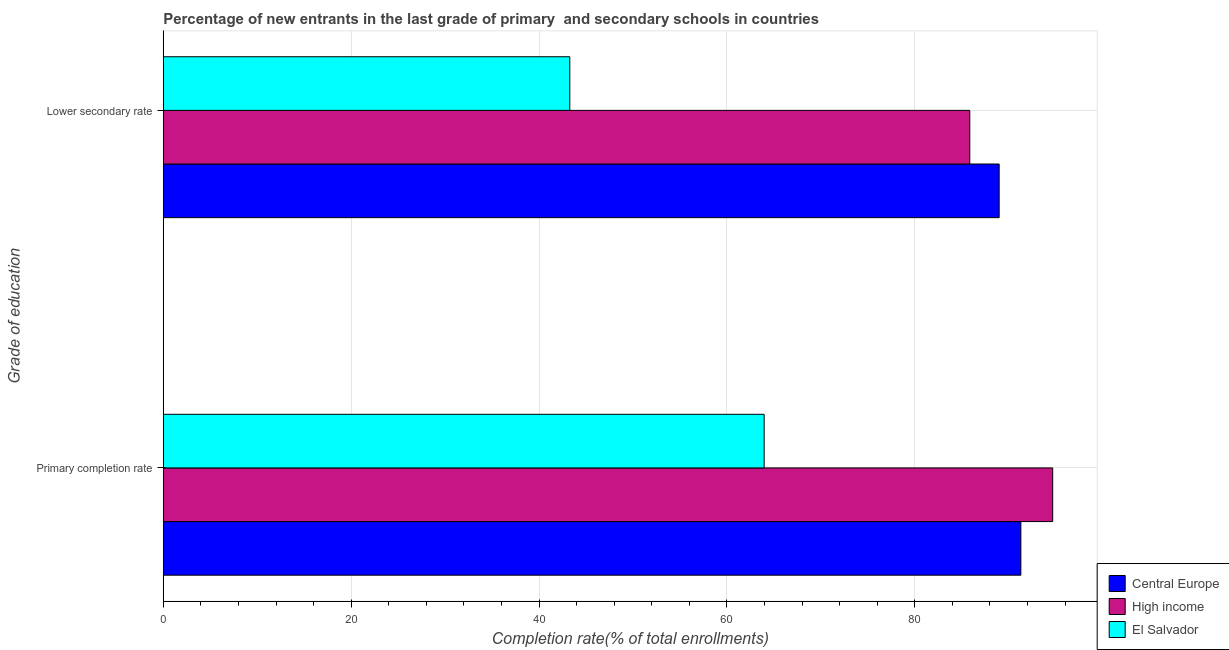Are the number of bars per tick equal to the number of legend labels?
Provide a short and direct response. Yes. How many bars are there on the 1st tick from the top?
Your answer should be compact. 3. How many bars are there on the 2nd tick from the bottom?
Offer a very short reply. 3. What is the label of the 1st group of bars from the top?
Make the answer very short. Lower secondary rate. What is the completion rate in primary schools in Central Europe?
Your response must be concise. 91.29. Across all countries, what is the maximum completion rate in secondary schools?
Ensure brevity in your answer.  88.98. Across all countries, what is the minimum completion rate in secondary schools?
Your answer should be very brief. 43.28. In which country was the completion rate in primary schools maximum?
Your answer should be compact. High income. In which country was the completion rate in secondary schools minimum?
Provide a short and direct response. El Salvador. What is the total completion rate in secondary schools in the graph?
Offer a terse response. 218.11. What is the difference between the completion rate in secondary schools in High income and that in Central Europe?
Your answer should be compact. -3.13. What is the difference between the completion rate in primary schools in High income and the completion rate in secondary schools in Central Europe?
Your answer should be very brief. 5.7. What is the average completion rate in primary schools per country?
Ensure brevity in your answer.  83.31. What is the difference between the completion rate in secondary schools and completion rate in primary schools in Central Europe?
Provide a succinct answer. -2.31. In how many countries, is the completion rate in secondary schools greater than 36 %?
Provide a succinct answer. 3. What is the ratio of the completion rate in secondary schools in Central Europe to that in High income?
Your answer should be very brief. 1.04. Is the completion rate in primary schools in El Salvador less than that in Central Europe?
Your answer should be compact. Yes. What does the 2nd bar from the bottom in Lower secondary rate represents?
Your answer should be very brief. High income. How many bars are there?
Keep it short and to the point. 6. What is the difference between two consecutive major ticks on the X-axis?
Provide a short and direct response. 20. Are the values on the major ticks of X-axis written in scientific E-notation?
Your answer should be very brief. No. Does the graph contain any zero values?
Provide a short and direct response. No. Where does the legend appear in the graph?
Make the answer very short. Bottom right. What is the title of the graph?
Provide a short and direct response. Percentage of new entrants in the last grade of primary  and secondary schools in countries. What is the label or title of the X-axis?
Make the answer very short. Completion rate(% of total enrollments). What is the label or title of the Y-axis?
Give a very brief answer. Grade of education. What is the Completion rate(% of total enrollments) in Central Europe in Primary completion rate?
Your answer should be compact. 91.29. What is the Completion rate(% of total enrollments) of High income in Primary completion rate?
Provide a succinct answer. 94.68. What is the Completion rate(% of total enrollments) of El Salvador in Primary completion rate?
Your answer should be very brief. 63.97. What is the Completion rate(% of total enrollments) in Central Europe in Lower secondary rate?
Your answer should be very brief. 88.98. What is the Completion rate(% of total enrollments) of High income in Lower secondary rate?
Provide a succinct answer. 85.86. What is the Completion rate(% of total enrollments) of El Salvador in Lower secondary rate?
Offer a terse response. 43.28. Across all Grade of education, what is the maximum Completion rate(% of total enrollments) in Central Europe?
Your answer should be compact. 91.29. Across all Grade of education, what is the maximum Completion rate(% of total enrollments) in High income?
Provide a succinct answer. 94.68. Across all Grade of education, what is the maximum Completion rate(% of total enrollments) in El Salvador?
Your answer should be very brief. 63.97. Across all Grade of education, what is the minimum Completion rate(% of total enrollments) of Central Europe?
Ensure brevity in your answer.  88.98. Across all Grade of education, what is the minimum Completion rate(% of total enrollments) of High income?
Provide a succinct answer. 85.86. Across all Grade of education, what is the minimum Completion rate(% of total enrollments) in El Salvador?
Ensure brevity in your answer.  43.28. What is the total Completion rate(% of total enrollments) in Central Europe in the graph?
Offer a terse response. 180.28. What is the total Completion rate(% of total enrollments) of High income in the graph?
Ensure brevity in your answer.  180.54. What is the total Completion rate(% of total enrollments) of El Salvador in the graph?
Your answer should be compact. 107.24. What is the difference between the Completion rate(% of total enrollments) in Central Europe in Primary completion rate and that in Lower secondary rate?
Provide a succinct answer. 2.31. What is the difference between the Completion rate(% of total enrollments) in High income in Primary completion rate and that in Lower secondary rate?
Keep it short and to the point. 8.83. What is the difference between the Completion rate(% of total enrollments) in El Salvador in Primary completion rate and that in Lower secondary rate?
Offer a very short reply. 20.69. What is the difference between the Completion rate(% of total enrollments) in Central Europe in Primary completion rate and the Completion rate(% of total enrollments) in High income in Lower secondary rate?
Make the answer very short. 5.44. What is the difference between the Completion rate(% of total enrollments) in Central Europe in Primary completion rate and the Completion rate(% of total enrollments) in El Salvador in Lower secondary rate?
Offer a very short reply. 48.02. What is the difference between the Completion rate(% of total enrollments) of High income in Primary completion rate and the Completion rate(% of total enrollments) of El Salvador in Lower secondary rate?
Ensure brevity in your answer.  51.41. What is the average Completion rate(% of total enrollments) in Central Europe per Grade of education?
Offer a very short reply. 90.14. What is the average Completion rate(% of total enrollments) in High income per Grade of education?
Make the answer very short. 90.27. What is the average Completion rate(% of total enrollments) in El Salvador per Grade of education?
Provide a short and direct response. 53.62. What is the difference between the Completion rate(% of total enrollments) of Central Europe and Completion rate(% of total enrollments) of High income in Primary completion rate?
Keep it short and to the point. -3.39. What is the difference between the Completion rate(% of total enrollments) of Central Europe and Completion rate(% of total enrollments) of El Salvador in Primary completion rate?
Give a very brief answer. 27.33. What is the difference between the Completion rate(% of total enrollments) in High income and Completion rate(% of total enrollments) in El Salvador in Primary completion rate?
Offer a terse response. 30.72. What is the difference between the Completion rate(% of total enrollments) in Central Europe and Completion rate(% of total enrollments) in High income in Lower secondary rate?
Offer a very short reply. 3.13. What is the difference between the Completion rate(% of total enrollments) of Central Europe and Completion rate(% of total enrollments) of El Salvador in Lower secondary rate?
Make the answer very short. 45.71. What is the difference between the Completion rate(% of total enrollments) of High income and Completion rate(% of total enrollments) of El Salvador in Lower secondary rate?
Keep it short and to the point. 42.58. What is the ratio of the Completion rate(% of total enrollments) in High income in Primary completion rate to that in Lower secondary rate?
Your answer should be very brief. 1.1. What is the ratio of the Completion rate(% of total enrollments) in El Salvador in Primary completion rate to that in Lower secondary rate?
Give a very brief answer. 1.48. What is the difference between the highest and the second highest Completion rate(% of total enrollments) in Central Europe?
Your response must be concise. 2.31. What is the difference between the highest and the second highest Completion rate(% of total enrollments) of High income?
Provide a succinct answer. 8.83. What is the difference between the highest and the second highest Completion rate(% of total enrollments) in El Salvador?
Give a very brief answer. 20.69. What is the difference between the highest and the lowest Completion rate(% of total enrollments) of Central Europe?
Ensure brevity in your answer.  2.31. What is the difference between the highest and the lowest Completion rate(% of total enrollments) in High income?
Give a very brief answer. 8.83. What is the difference between the highest and the lowest Completion rate(% of total enrollments) in El Salvador?
Make the answer very short. 20.69. 